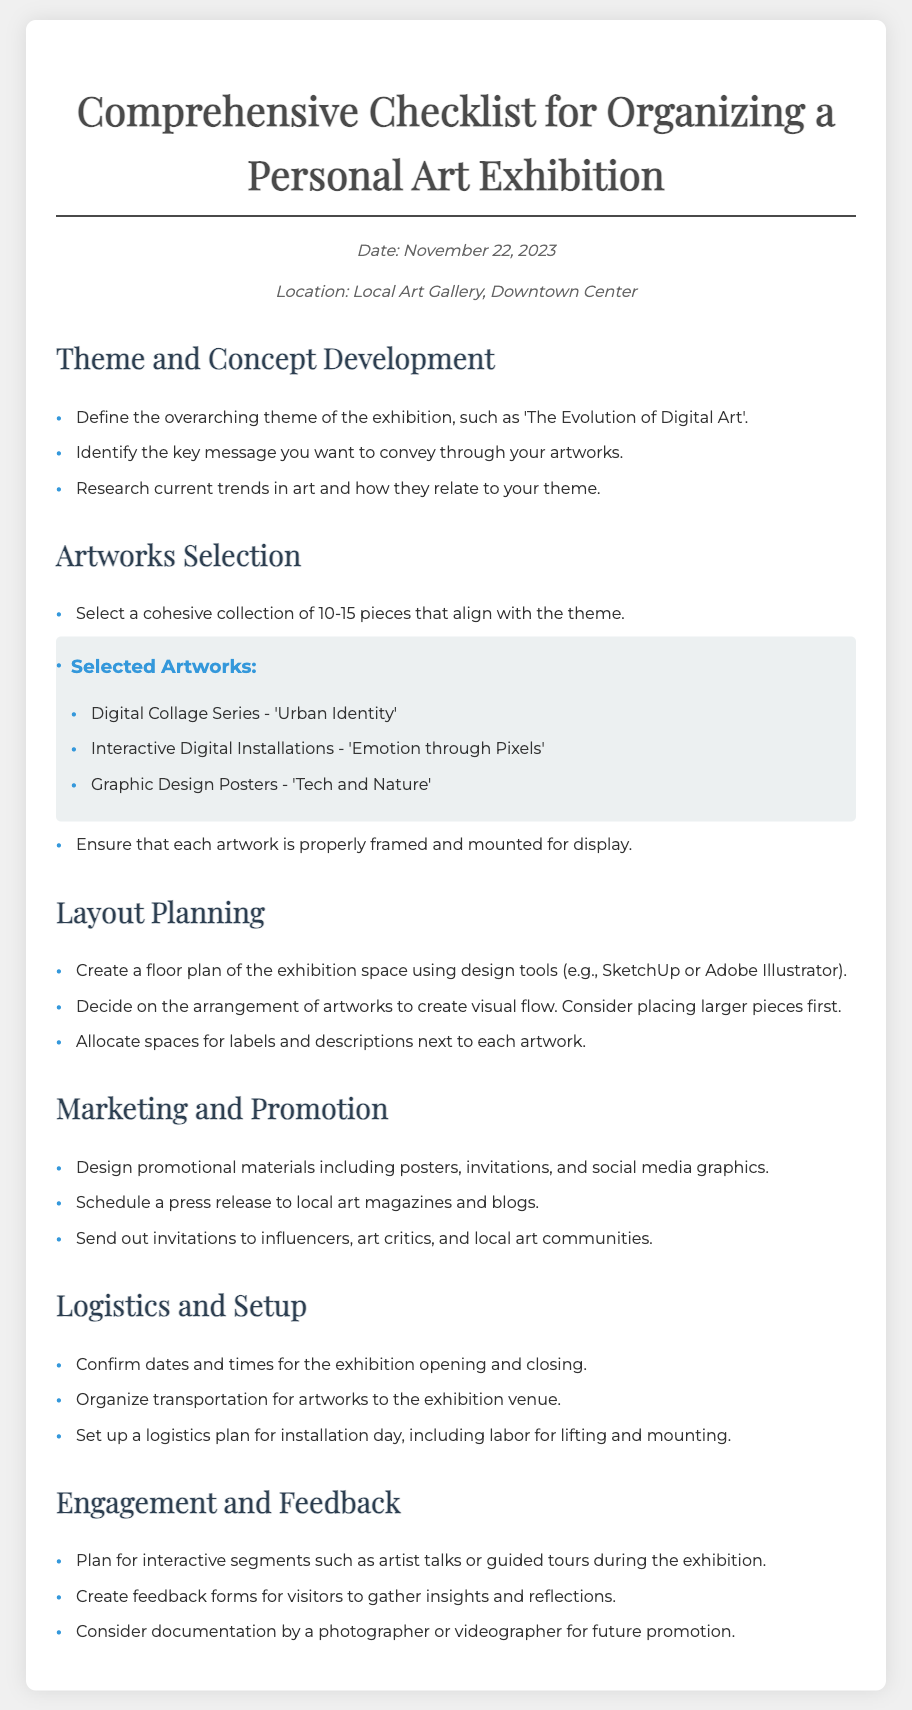What is the date of the exhibition? The date of the exhibition is mentioned in the information section of the document.
Answer: November 22, 2023 What is the main theme of the exhibition? The theme is defined in the 'Theme and Concept Development' section.
Answer: The Evolution of Digital Art How many selected artworks are listed? The number of selected artworks is stated within the 'Selected Artworks' subsection.
Answer: 3 Which design tools are suggested for creating a floor plan? The tools are recommended in the 'Layout Planning' section.
Answer: SketchUp or Adobe Illustrator What type of interactive segments are planned for visitor engagement? The types of segments are described in the 'Engagement and Feedback' section.
Answer: Artist talks or guided tours What color is used for the bullet points in the artwork list? The color is specified in the CSS styling of the document.
Answer: Blue Which local area is the venue located in? The location is provided in the information section of the document.
Answer: Downtown Center What should be included in promotional materials? This is outlined in the 'Marketing and Promotion' section.
Answer: Posters, invitations, and social media graphics 